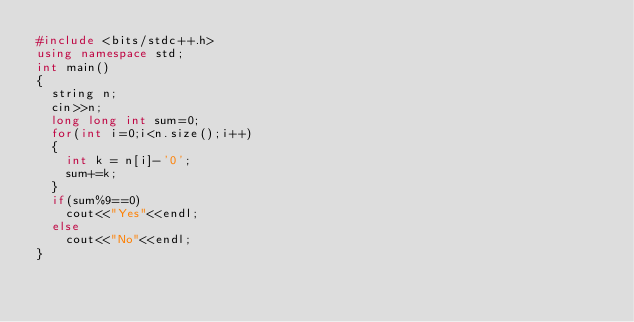Convert code to text. <code><loc_0><loc_0><loc_500><loc_500><_C++_>#include <bits/stdc++.h> 
using namespace std; 
int main()
{
  string n;
  cin>>n;
  long long int sum=0;
  for(int i=0;i<n.size();i++)
  {
    int k = n[i]-'0';
    sum+=k;
  }
  if(sum%9==0)
    cout<<"Yes"<<endl;
  else
    cout<<"No"<<endl;
}
</code> 